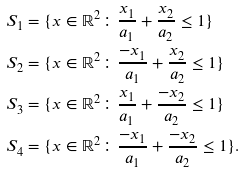Convert formula to latex. <formula><loc_0><loc_0><loc_500><loc_500>S _ { 1 } & = \{ x \in \mathbb { R } ^ { 2 } \colon \frac { x _ { 1 } } { a _ { 1 } } + \frac { x _ { 2 } } { a _ { 2 } } \leq 1 \} \\ S _ { 2 } & = \{ x \in \mathbb { R } ^ { 2 } \colon \frac { - x _ { 1 } } { a _ { 1 } } + \frac { x _ { 2 } } { a _ { 2 } } \leq 1 \} \\ S _ { 3 } & = \{ x \in \mathbb { R } ^ { 2 } \colon \frac { x _ { 1 } } { a _ { 1 } } + \frac { - x _ { 2 } } { a _ { 2 } } \leq 1 \} \\ S _ { 4 } & = \{ x \in \mathbb { R } ^ { 2 } \colon \frac { - x _ { 1 } } { a _ { 1 } } + \frac { - x _ { 2 } } { a _ { 2 } } \leq 1 \} .</formula> 